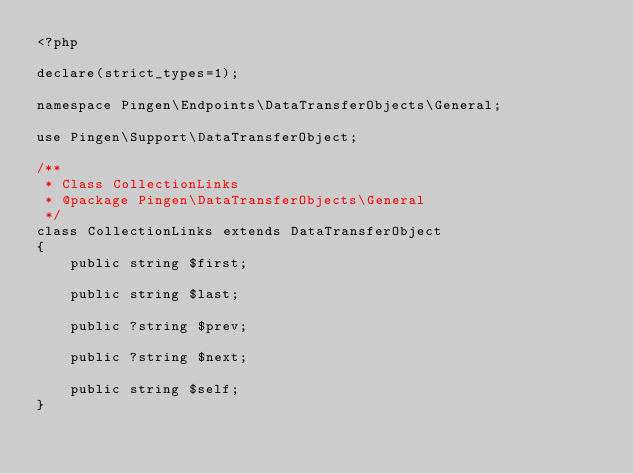Convert code to text. <code><loc_0><loc_0><loc_500><loc_500><_PHP_><?php

declare(strict_types=1);

namespace Pingen\Endpoints\DataTransferObjects\General;

use Pingen\Support\DataTransferObject;

/**
 * Class CollectionLinks
 * @package Pingen\DataTransferObjects\General
 */
class CollectionLinks extends DataTransferObject
{
    public string $first;

    public string $last;

    public ?string $prev;

    public ?string $next;

    public string $self;
}
</code> 